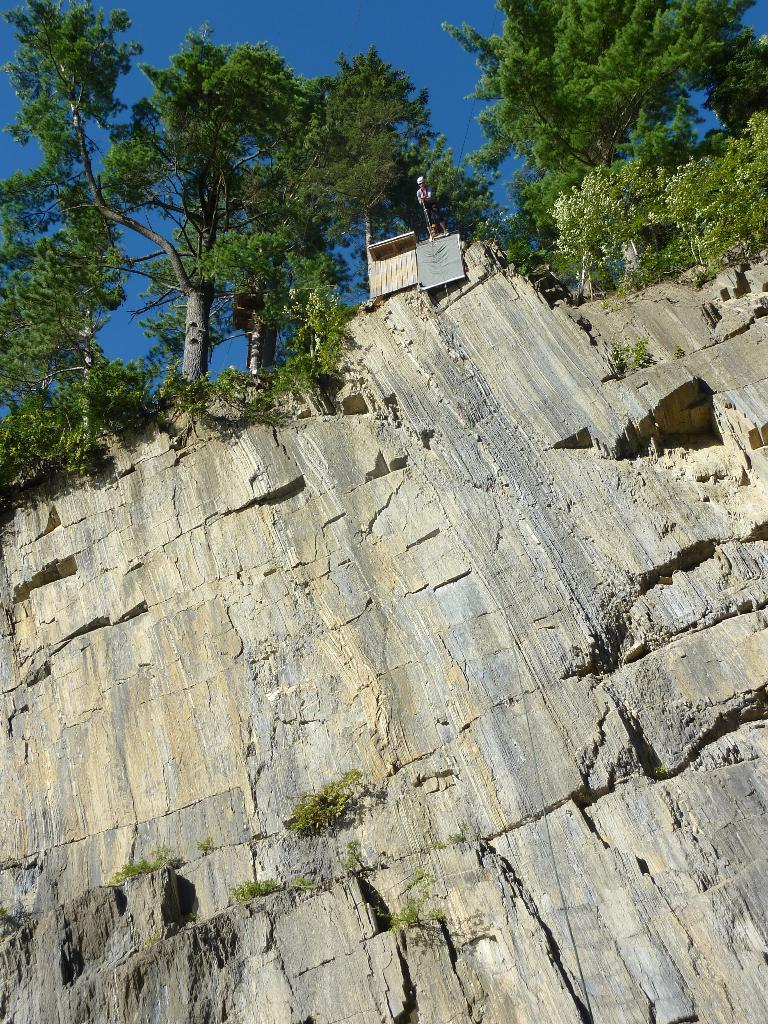What is present on the wall in the image? There is no specific detail about the wall in the image. What type of vegetation can be seen in the image? There are plants and trees in the image. Can you describe the human in the image? There is a human in the image, but no specific details about the person are provided. What other objects can be seen in the image? There are unspecified objects in the image. What is visible in the background of the image? The sky is visible in the background of the image. What rule is being exchanged between the table and the plants in the image? There is no rule or exchange between the table and the plants in the image, as these objects are not interacting with each other. 